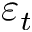Convert formula to latex. <formula><loc_0><loc_0><loc_500><loc_500>\varepsilon _ { t }</formula> 